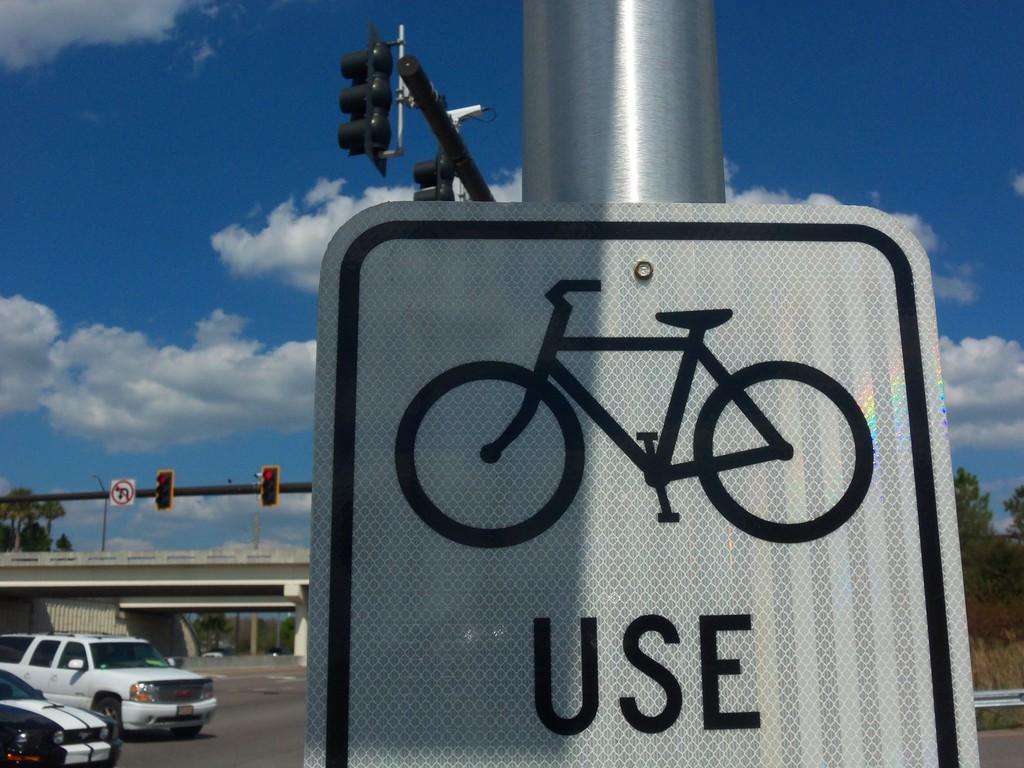What should the bikes do?
Make the answer very short. Unanswerable. 